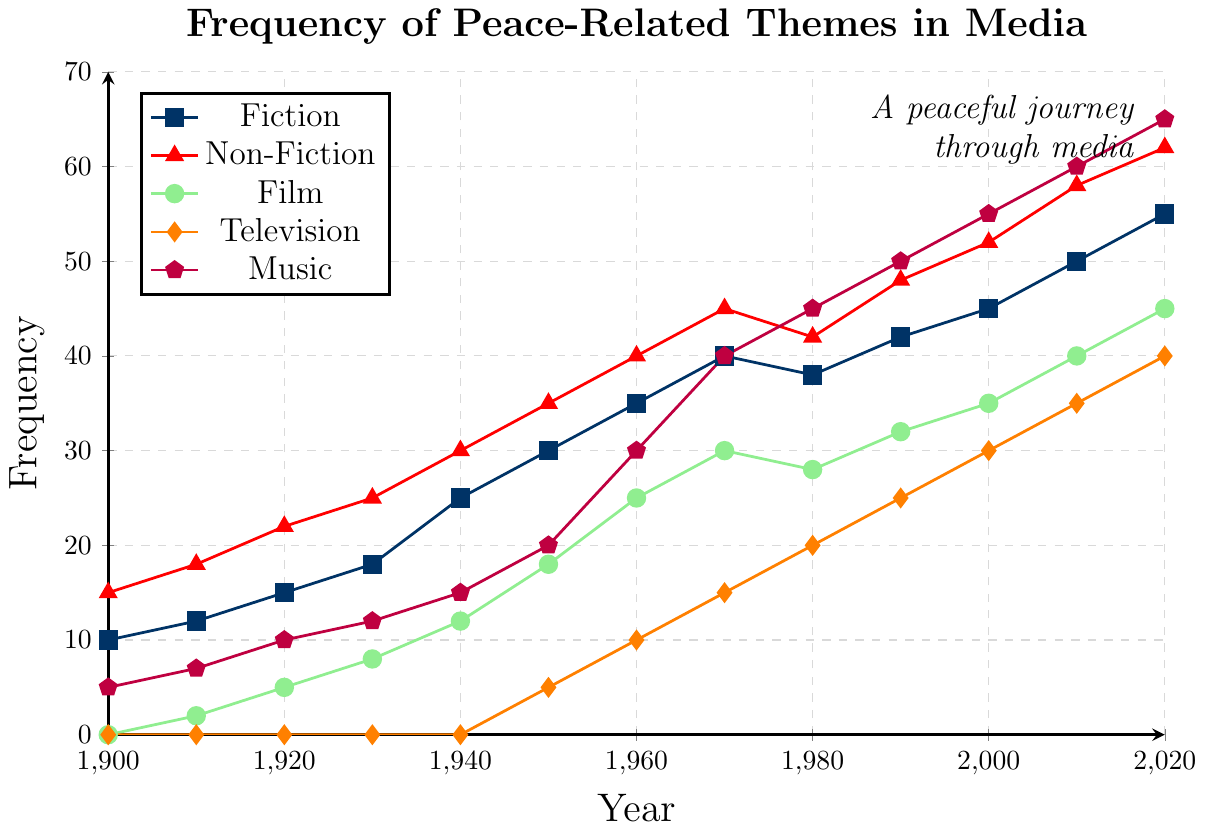Which genre had the highest frequency of peace-related themes in 2020? To determine the genre with the highest frequency in 2020, look at the endpoint values for each genre on the x-axis at 2020. Fiction had 55, Non-Fiction 62, Film 45, Television 40, and Music 65. The highest value is for Music.
Answer: Music How did the frequency of peace-related themes in television change from 1950 to 1970? Check the frequency values for television at 1950 and 1970. In 1950, the value is 5, and in 1970, the value is 15. Calculate the difference: 15 - 5 = 10. The frequency increased by 10.
Answer: Increased by 10 What is the average frequency of peace-related themes in Fiction from 1900 to 2020? To calculate the average, sum the frequencies of Fiction from 1900 to 2020: 10 + 12 + 15 + 18 + 25 + 30 + 35 + 40 + 38 + 42 + 45 + 50 + 55 = 415. There are 13 data points, so the average is 415 / 13 ≈ 31.9.
Answer: 31.9 Which genre saw the largest increase in peace-related themes between 1910 and 1960? Calculate the increase for each genre from 1910 to 1960 by subtracting the 1910 value from the 1960 value: Fiction: 35 - 12 = 23, Non-Fiction: 40 - 18 = 22, Film: 25 - 2 = 23, Television: 10 - 0 = 10, Music: 30 - 7 = 23. Fiction, Film, and Music all saw an increase of 23, so the largest increase is seen in these three genres.
Answer: Fiction, Film, Music At what point did the frequency of peace-related themes in Film surpass 25? Look at the Film data points to identify when the frequency surpasses 25. In 1960, the value is 25, and in 1970, it is 30. Therefore, it surpasses 25 between 1960 and 1970.
Answer: Between 1960 and 1970 Compare the trends of peace-related themes in Fiction and Non-Fiction from 1980 to 2000. To compare the trends, look at the values for Fiction and Non-Fiction in 1980, 1990, and 2000. Fiction: 1980 (38), 1990 (42), 2000 (45); Non-Fiction: 1980 (42), 1990 (48), 2000 (52). Both genres show an increasing trend, with Fiction increasing by 7 and Non-Fiction by 10 over the period.
Answer: Both increased, but Non-Fiction increased more What is the total increase in frequency of peace-related themes in Music from 1900 to 2020? To find the total increase, subtract the 1900 value from the 2020 value for Music: 65 - 5 = 60.
Answer: 60 What was the rate of change of peace-related themes in Non-Fiction from 2000 to 2010? Calculate the rate of change by subtracting the 2000 value from the 2010 value and then dividing by the number of years. Non-Fiction values: 2010 (58) and 2000 (52), so the rate of change is (58 - 52) / (2010 - 2000) = 6 / 10 = 0.6.
Answer: 0.6 per year Between which decades did the frequency of peace-related themes in Fiction see the smallest increase? Calculate the increase in Fiction for each decade and compare: 1900-1910 (2), 1910-1920 (3), 1920-1930 (3), 1930-1940 (7), 1940-1950 (5), 1950-1960 (5), 1960-1970 (5), 1970-1980 (-2), 1980-1990 (4), 1990-2000 (3), 2000-2010 (5), 2010-2020 (5). The smallest increase is between 1970-1980, with a decrease of 2.
Answer: 1970-1980 Which genre had consistently non-zero frequencies since the 1900s? Identify genres with non-zero frequencies in 1900 and onwards. Only Fiction and Non-Fiction had non-zero frequencies in 1900.
Answer: Fiction, Non-Fiction 